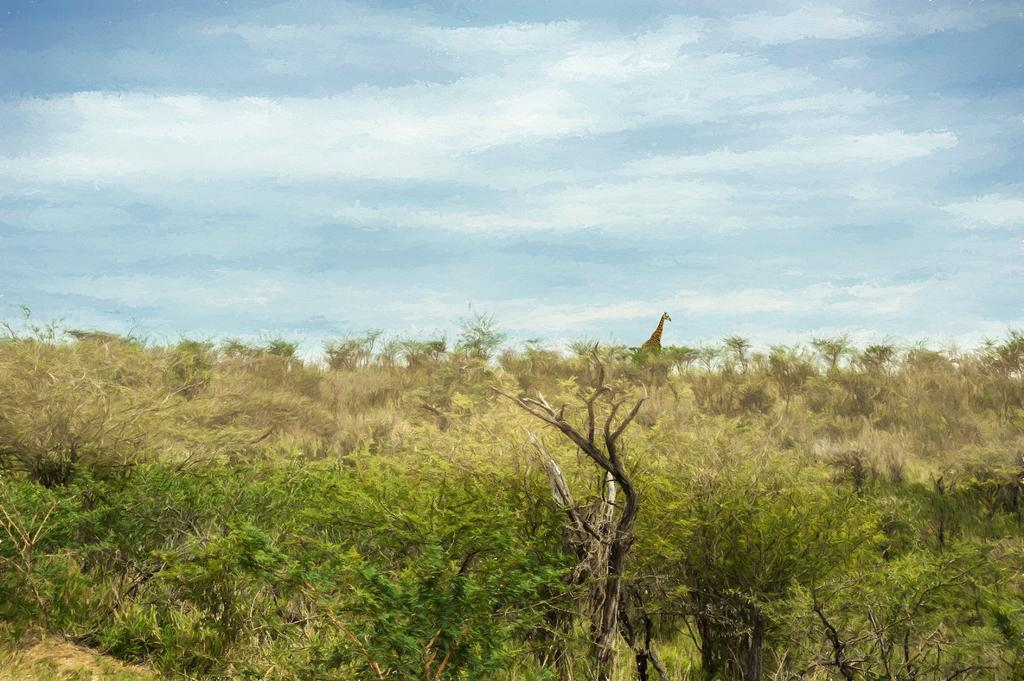What type of vegetation is visible in the image? There are trees in front of the image. What animal can be seen in the image? There is a giraffe in the image. What part of the natural environment is visible in the image? The sky is visible in the background of the image. What type of scarf is the giraffe wearing in the image? There is no scarf present in the image, and the giraffe is not wearing any clothing. What story is the giraffe telling in the image? There is no indication that the giraffe is telling a story in the image. 